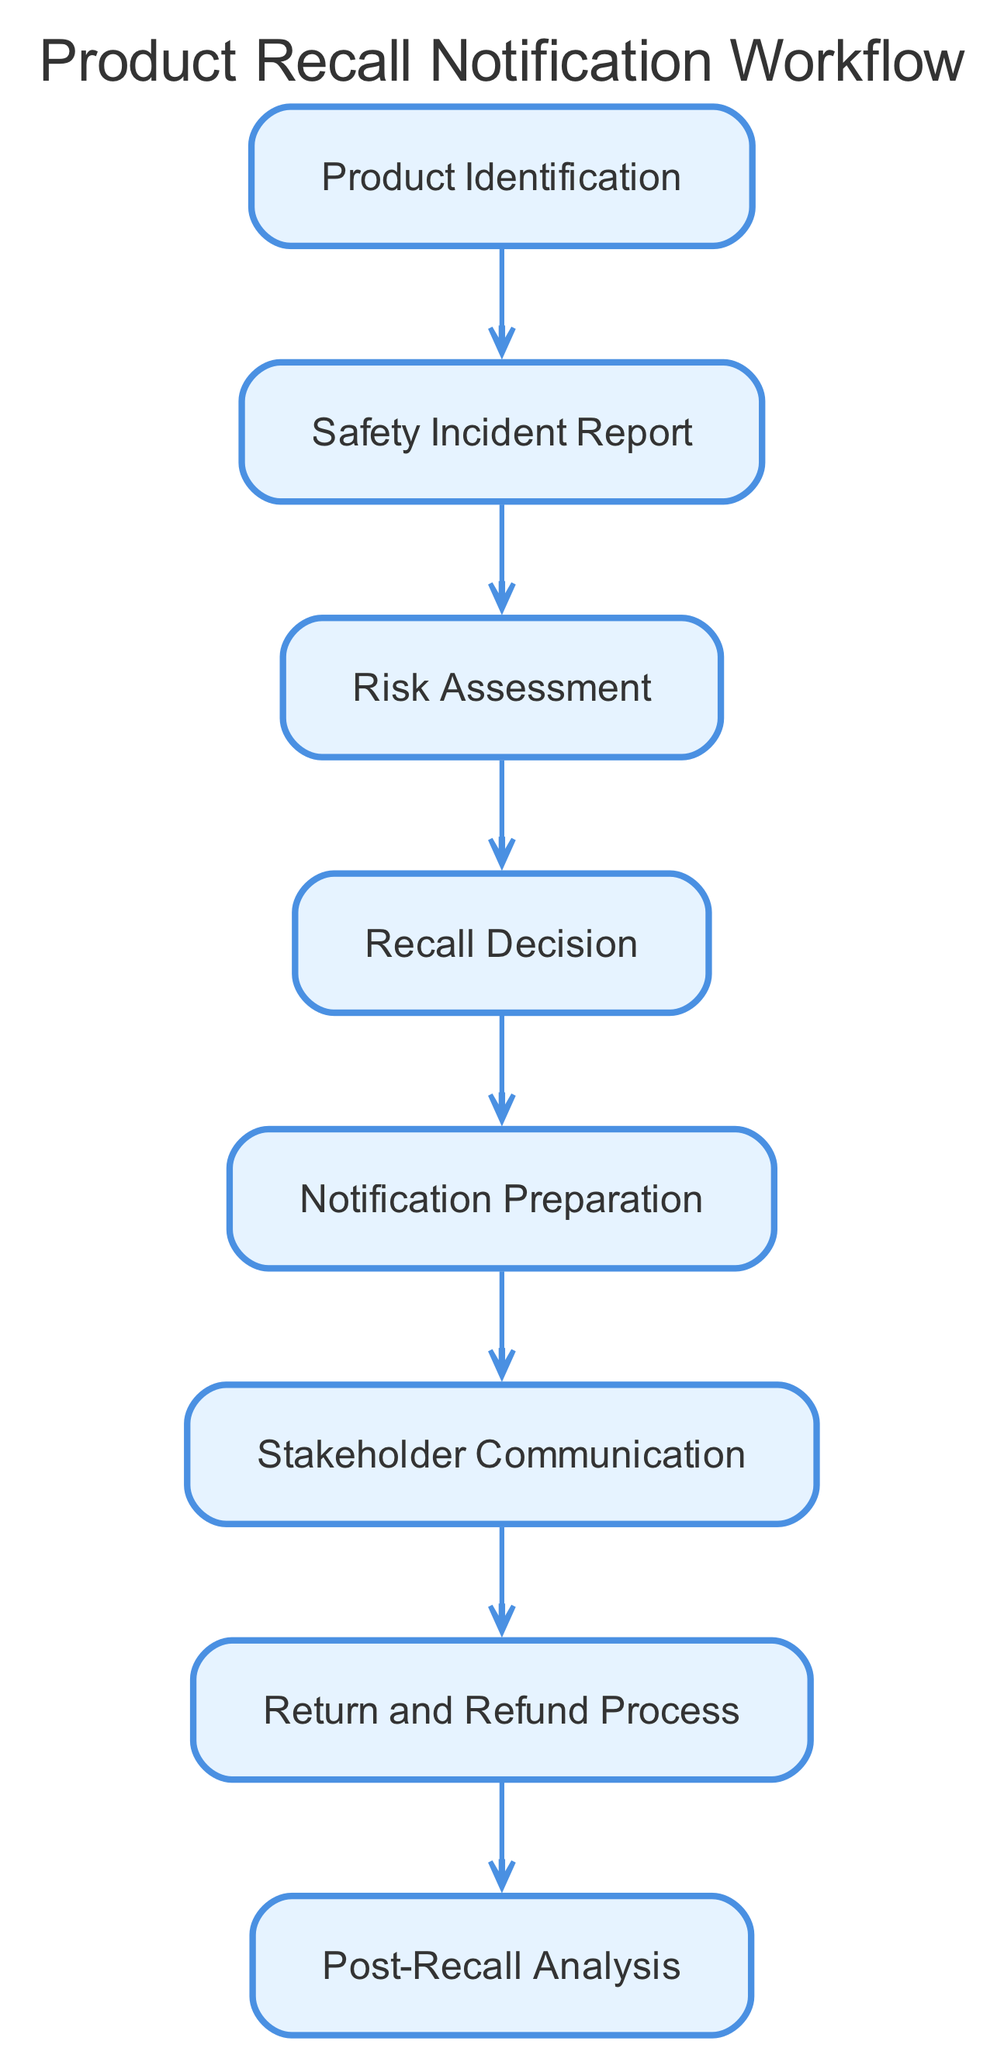What is the first step in the product recall workflow? The first step in the workflow is represented by the node “Product Identification”. It is the starting point where the product involved in the safety issue is identified.
Answer: Product Identification How many nodes are in the diagram? To find the number of nodes, we can count each unique node listed in the data. There are 8 nodes total: Product Identification, Safety Incident Report, Risk Assessment, Recall Decision, Notification Preparation, Stakeholder Communication, Return and Refund Process, and Post-Recall Analysis.
Answer: 8 What is the outcome of the Safety Incident Report node? The Safety Incident Report node leads to the next step in the workflow, which is the "Risk Assessment" node. This indicates that after collecting safety incident reports, the next action is to assess the associated risks.
Answer: Risk Assessment What follows the Recall Decision in the workflow? The node that follows the “Recall Decision” is “Notification Preparation”. The diagram shows an edge pointing from Recall Decision to Notification Preparation, demonstrating the flow of process.
Answer: Notification Preparation Which node is the last in the workflow? The last node in the workflow is “Post-Recall Analysis”. This node is at the end of the directed graph, concluding the recall notification process with an analysis step.
Answer: Post-Recall Analysis How many edges connect the Risk Assessment node to other nodes? The Risk Assessment node connects to one other node, which is the Recall Decision node. An edge indicates a directed relationship in the workflow.
Answer: 1 What process occurs after informing stakeholders about the recall? After the Stakeholder Communication node, the next process is the “Return and Refund Process”. This indicates that after informing stakeholders, the workflow continues to establish return procedures.
Answer: Return and Refund Process What is the relationship between Product Identification and Safety Incident Report? The relationship is a directed edge indicating that once a product has been identified, the next action is to collect reports related to that product's safety incidents. It shows the sequential flow in the workflow.
Answer: Collection of reports 